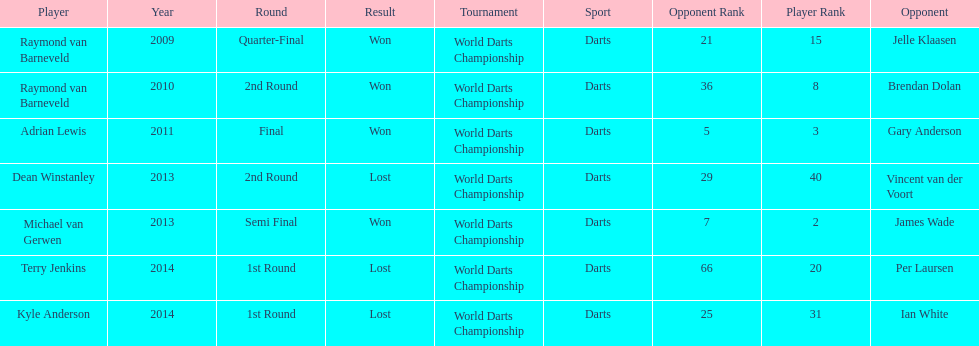How many champions were from norway? 0. 